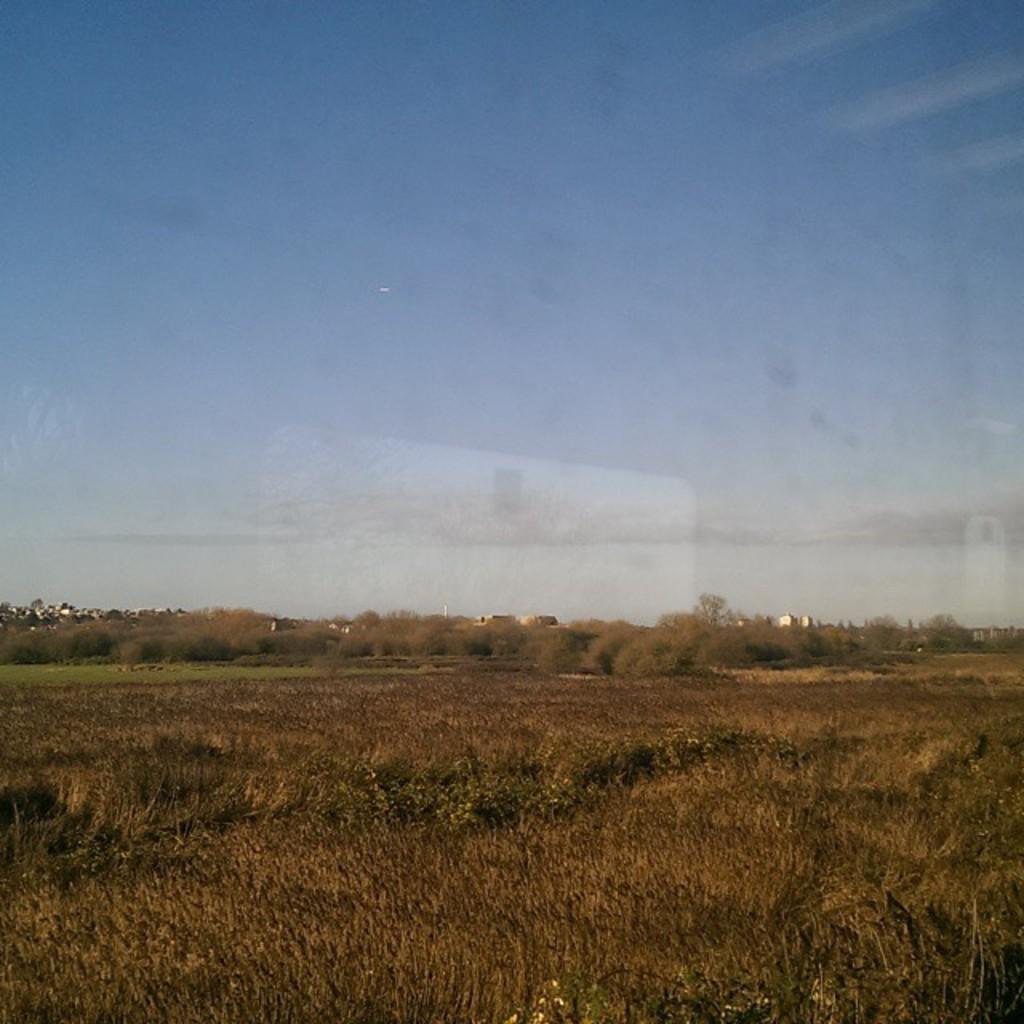Can you describe this image briefly? In this picture I can see grass, there are trees, and in the background there is the sky. 